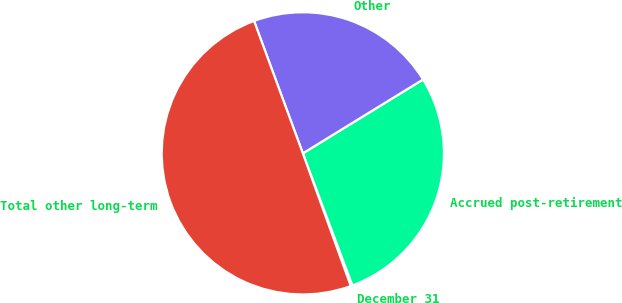Convert chart. <chart><loc_0><loc_0><loc_500><loc_500><pie_chart><fcel>December 31<fcel>Accrued post-retirement<fcel>Other<fcel>Total other long-term<nl><fcel>0.2%<fcel>28.05%<fcel>21.85%<fcel>49.9%<nl></chart> 